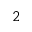Convert formula to latex. <formula><loc_0><loc_0><loc_500><loc_500>_ { 2 }</formula> 